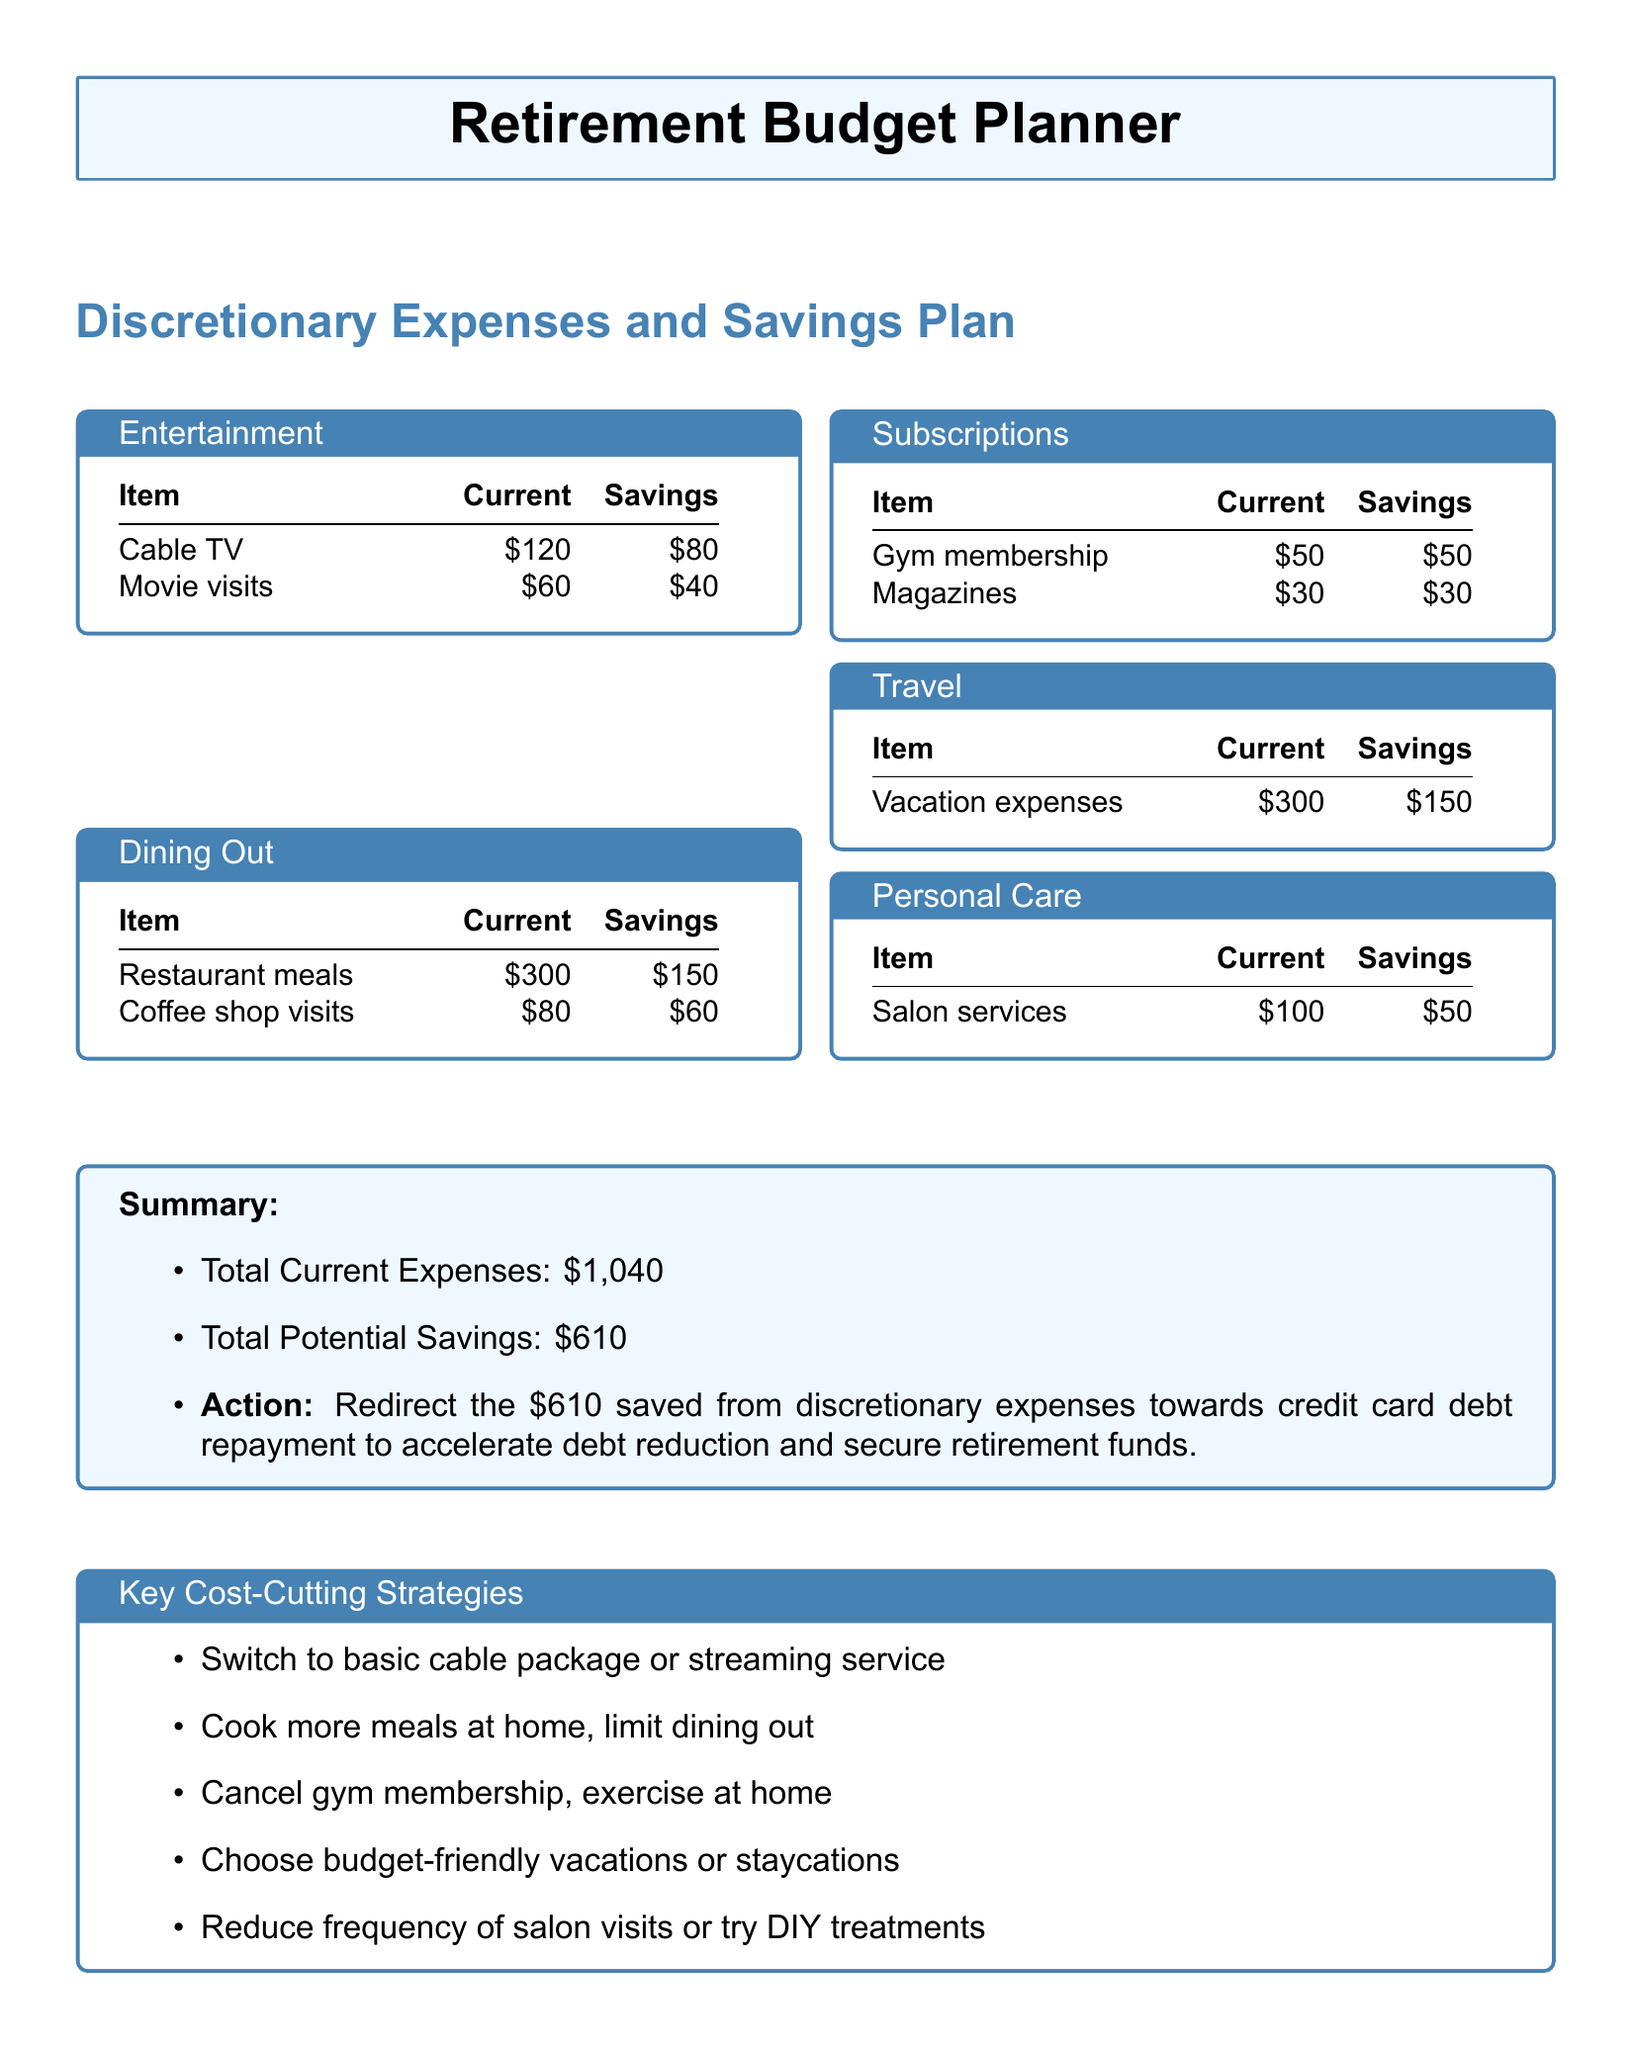What is the total amount for discretionary expenses? The total amount for discretionary expenses is provided in the summary section, which adds up all the individual discretionary expenses listed.
Answer: $1,040 How much can be potentially saved from dining out? The potential savings from dining out are specifically mentioned under the dining out section, summing up restaurant meals and coffee shop visits savings.
Answer: $210 What is one cost-cutting strategy suggested in the document? The document lists several cost-cutting strategies; one is found in the key strategies section.
Answer: Cook more meals at home, limit dining out What are the current expenses for salon services? The current expenses for salon services are specified in the personal care section of the document.
Answer: $100 How much money can be saved by switching to a basic cable package? The possible saving from switching to a basic cable package is indicated under the entertainment section, specifically for cable TV expenses.
Answer: $80 What is the potential saving from vacation expenses? The potential saving from vacation expenses is provided in the travel section by subtracting the current expenses from the potential savings.
Answer: $150 What is the action recommended at the end of the document? The summary section concludes with a clear recommendation based on the potential savings identified in the document.
Answer: Redirect the $610 saved from discretionary expenses towards credit card debt repayment 